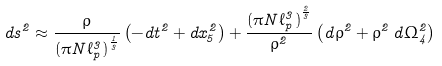Convert formula to latex. <formula><loc_0><loc_0><loc_500><loc_500>d s ^ { 2 } \approx \frac { \rho } { { ( \pi N \ell _ { p } ^ { 3 } ) } ^ { \frac { 1 } { 3 } } } \left ( - d t ^ { 2 } + d x _ { 5 } ^ { 2 } \right ) + \frac { { ( \pi N \ell _ { p } ^ { 3 } ) } ^ { \frac { 2 } { 3 } } } { \rho ^ { 2 } } \left ( d \rho ^ { 2 } + \rho ^ { 2 } \, d \Omega _ { 4 } ^ { 2 } \right )</formula> 